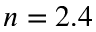Convert formula to latex. <formula><loc_0><loc_0><loc_500><loc_500>n = 2 . 4</formula> 